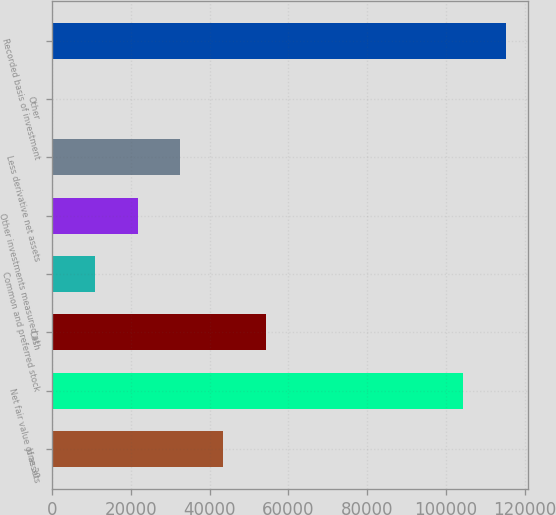Convert chart to OTSL. <chart><loc_0><loc_0><loc_500><loc_500><bar_chart><fcel>June 30<fcel>Net fair value of assets<fcel>Cash<fcel>Common and preferred stock<fcel>Other investments measured at<fcel>Less derivative net assets<fcel>Other<fcel>Recorded basis of investment<nl><fcel>43424<fcel>104369<fcel>54279<fcel>10859<fcel>21714<fcel>32569<fcel>4<fcel>115224<nl></chart> 